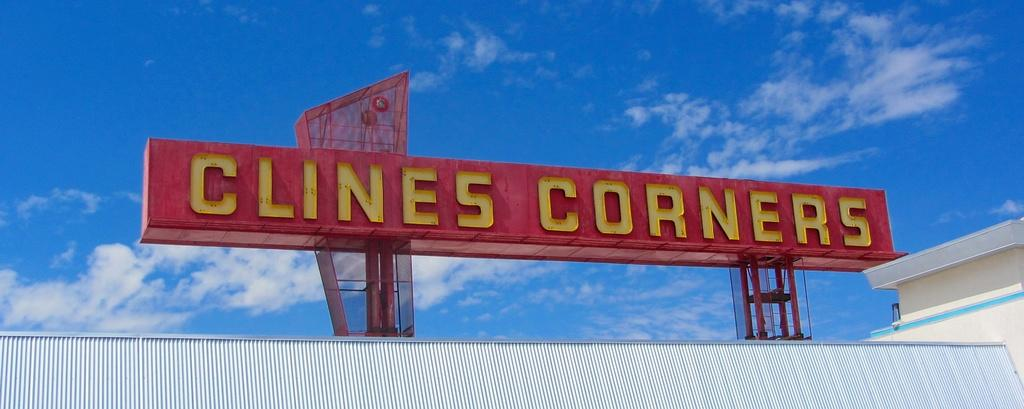<image>
Relay a brief, clear account of the picture shown. A big red sign has yellow lettering reading Clines Corners. 